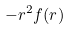<formula> <loc_0><loc_0><loc_500><loc_500>- r ^ { 2 } f ( r )</formula> 